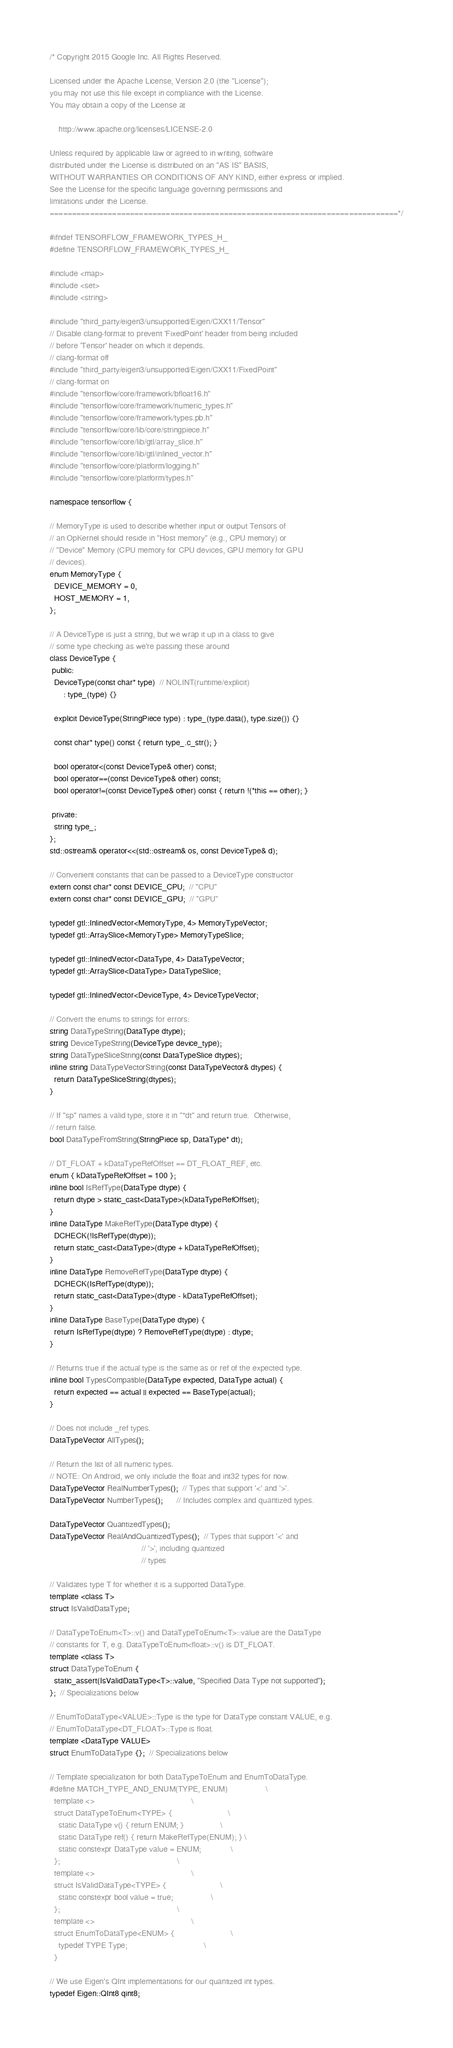Convert code to text. <code><loc_0><loc_0><loc_500><loc_500><_C_>/* Copyright 2015 Google Inc. All Rights Reserved.

Licensed under the Apache License, Version 2.0 (the "License");
you may not use this file except in compliance with the License.
You may obtain a copy of the License at

    http://www.apache.org/licenses/LICENSE-2.0

Unless required by applicable law or agreed to in writing, software
distributed under the License is distributed on an "AS IS" BASIS,
WITHOUT WARRANTIES OR CONDITIONS OF ANY KIND, either express or implied.
See the License for the specific language governing permissions and
limitations under the License.
==============================================================================*/

#ifndef TENSORFLOW_FRAMEWORK_TYPES_H_
#define TENSORFLOW_FRAMEWORK_TYPES_H_

#include <map>
#include <set>
#include <string>

#include "third_party/eigen3/unsupported/Eigen/CXX11/Tensor"
// Disable clang-format to prevent 'FixedPoint' header from being included
// before 'Tensor' header on which it depends.
// clang-format off
#include "third_party/eigen3/unsupported/Eigen/CXX11/FixedPoint"
// clang-format on
#include "tensorflow/core/framework/bfloat16.h"
#include "tensorflow/core/framework/numeric_types.h"
#include "tensorflow/core/framework/types.pb.h"
#include "tensorflow/core/lib/core/stringpiece.h"
#include "tensorflow/core/lib/gtl/array_slice.h"
#include "tensorflow/core/lib/gtl/inlined_vector.h"
#include "tensorflow/core/platform/logging.h"
#include "tensorflow/core/platform/types.h"

namespace tensorflow {

// MemoryType is used to describe whether input or output Tensors of
// an OpKernel should reside in "Host memory" (e.g., CPU memory) or
// "Device" Memory (CPU memory for CPU devices, GPU memory for GPU
// devices).
enum MemoryType {
  DEVICE_MEMORY = 0,
  HOST_MEMORY = 1,
};

// A DeviceType is just a string, but we wrap it up in a class to give
// some type checking as we're passing these around
class DeviceType {
 public:
  DeviceType(const char* type)  // NOLINT(runtime/explicit)
      : type_(type) {}

  explicit DeviceType(StringPiece type) : type_(type.data(), type.size()) {}

  const char* type() const { return type_.c_str(); }

  bool operator<(const DeviceType& other) const;
  bool operator==(const DeviceType& other) const;
  bool operator!=(const DeviceType& other) const { return !(*this == other); }

 private:
  string type_;
};
std::ostream& operator<<(std::ostream& os, const DeviceType& d);

// Convenient constants that can be passed to a DeviceType constructor
extern const char* const DEVICE_CPU;  // "CPU"
extern const char* const DEVICE_GPU;  // "GPU"

typedef gtl::InlinedVector<MemoryType, 4> MemoryTypeVector;
typedef gtl::ArraySlice<MemoryType> MemoryTypeSlice;

typedef gtl::InlinedVector<DataType, 4> DataTypeVector;
typedef gtl::ArraySlice<DataType> DataTypeSlice;

typedef gtl::InlinedVector<DeviceType, 4> DeviceTypeVector;

// Convert the enums to strings for errors:
string DataTypeString(DataType dtype);
string DeviceTypeString(DeviceType device_type);
string DataTypeSliceString(const DataTypeSlice dtypes);
inline string DataTypeVectorString(const DataTypeVector& dtypes) {
  return DataTypeSliceString(dtypes);
}

// If "sp" names a valid type, store it in "*dt" and return true.  Otherwise,
// return false.
bool DataTypeFromString(StringPiece sp, DataType* dt);

// DT_FLOAT + kDataTypeRefOffset == DT_FLOAT_REF, etc.
enum { kDataTypeRefOffset = 100 };
inline bool IsRefType(DataType dtype) {
  return dtype > static_cast<DataType>(kDataTypeRefOffset);
}
inline DataType MakeRefType(DataType dtype) {
  DCHECK(!IsRefType(dtype));
  return static_cast<DataType>(dtype + kDataTypeRefOffset);
}
inline DataType RemoveRefType(DataType dtype) {
  DCHECK(IsRefType(dtype));
  return static_cast<DataType>(dtype - kDataTypeRefOffset);
}
inline DataType BaseType(DataType dtype) {
  return IsRefType(dtype) ? RemoveRefType(dtype) : dtype;
}

// Returns true if the actual type is the same as or ref of the expected type.
inline bool TypesCompatible(DataType expected, DataType actual) {
  return expected == actual || expected == BaseType(actual);
}

// Does not include _ref types.
DataTypeVector AllTypes();

// Return the list of all numeric types.
// NOTE: On Android, we only include the float and int32 types for now.
DataTypeVector RealNumberTypes();  // Types that support '<' and '>'.
DataTypeVector NumberTypes();      // Includes complex and quantized types.

DataTypeVector QuantizedTypes();
DataTypeVector RealAndQuantizedTypes();  // Types that support '<' and
                                         // '>', including quantized
                                         // types

// Validates type T for whether it is a supported DataType.
template <class T>
struct IsValidDataType;

// DataTypeToEnum<T>::v() and DataTypeToEnum<T>::value are the DataType
// constants for T, e.g. DataTypeToEnum<float>::v() is DT_FLOAT.
template <class T>
struct DataTypeToEnum {
  static_assert(IsValidDataType<T>::value, "Specified Data Type not supported");
};  // Specializations below

// EnumToDataType<VALUE>::Type is the type for DataType constant VALUE, e.g.
// EnumToDataType<DT_FLOAT>::Type is float.
template <DataType VALUE>
struct EnumToDataType {};  // Specializations below

// Template specialization for both DataTypeToEnum and EnumToDataType.
#define MATCH_TYPE_AND_ENUM(TYPE, ENUM)                 \
  template <>                                           \
  struct DataTypeToEnum<TYPE> {                         \
    static DataType v() { return ENUM; }                \
    static DataType ref() { return MakeRefType(ENUM); } \
    static constexpr DataType value = ENUM;             \
  };                                                    \
  template <>                                           \
  struct IsValidDataType<TYPE> {                        \
    static constexpr bool value = true;                 \
  };                                                    \
  template <>                                           \
  struct EnumToDataType<ENUM> {                         \
    typedef TYPE Type;                                  \
  }

// We use Eigen's QInt implementations for our quantized int types.
typedef Eigen::QInt8 qint8;</code> 